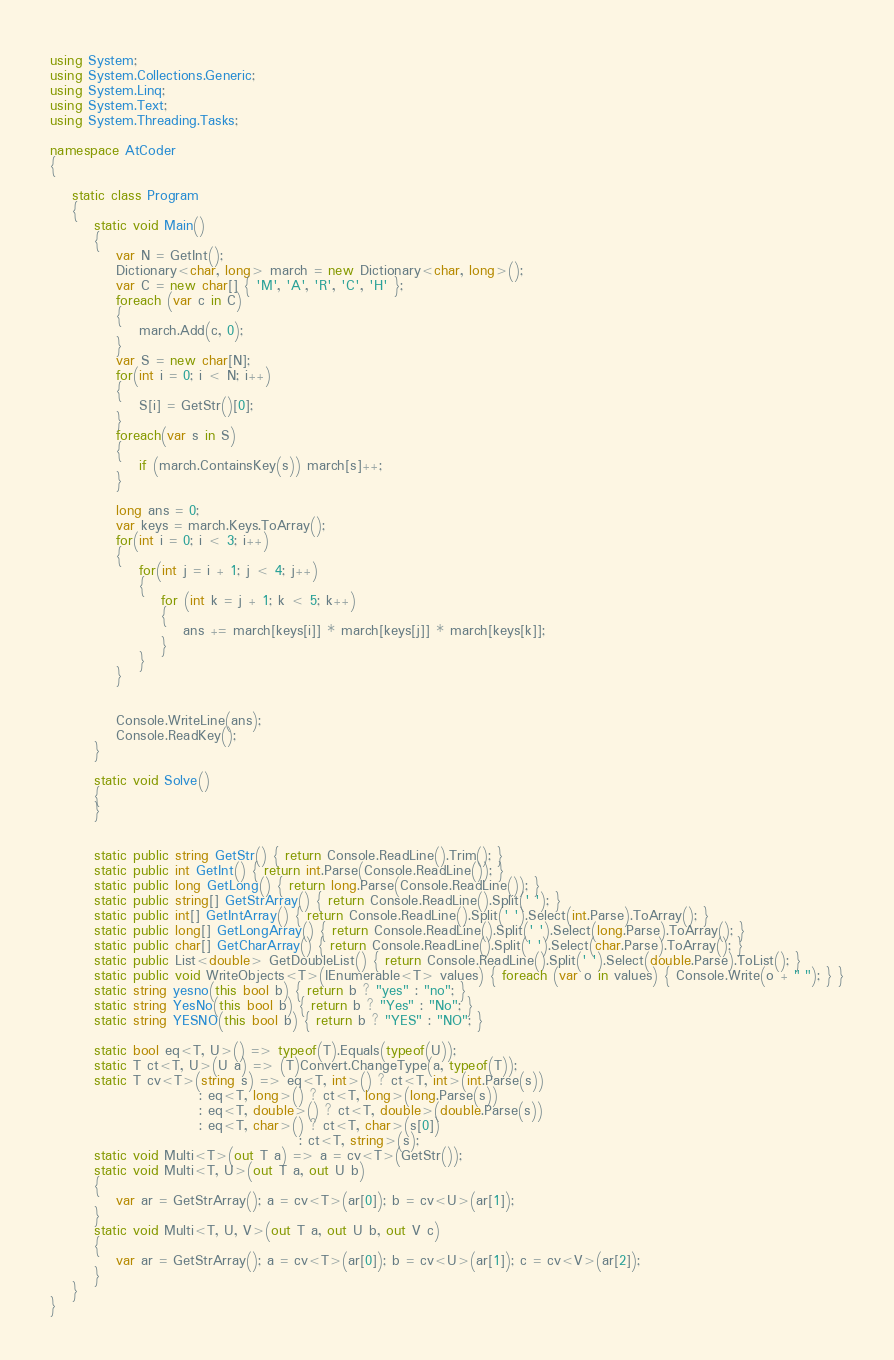<code> <loc_0><loc_0><loc_500><loc_500><_C#_>using System;
using System.Collections.Generic;
using System.Linq;
using System.Text;
using System.Threading.Tasks;

namespace AtCoder
{

    static class Program
    {
        static void Main()
        {
            var N = GetInt();
            Dictionary<char, long> march = new Dictionary<char, long>();
            var C = new char[] { 'M', 'A', 'R', 'C', 'H' };
            foreach (var c in C)
            {
                march.Add(c, 0);
            }
            var S = new char[N];
            for(int i = 0; i < N; i++)
            {
                S[i] = GetStr()[0];
            }
            foreach(var s in S)
            {
                if (march.ContainsKey(s)) march[s]++;
            }

            long ans = 0;
            var keys = march.Keys.ToArray();
            for(int i = 0; i < 3; i++)
            {
                for(int j = i + 1; j < 4; j++)
                {
                    for (int k = j + 1; k < 5; k++)
                    {
                        ans += march[keys[i]] * march[keys[j]] * march[keys[k]];
                    }
                }
            }


            Console.WriteLine(ans);
            Console.ReadKey();
        }

        static void Solve()
        {
        }


        static public string GetStr() { return Console.ReadLine().Trim(); }
        static public int GetInt() { return int.Parse(Console.ReadLine()); }
        static public long GetLong() { return long.Parse(Console.ReadLine()); }
        static public string[] GetStrArray() { return Console.ReadLine().Split(' '); }
        static public int[] GetIntArray() { return Console.ReadLine().Split(' ').Select(int.Parse).ToArray(); }
        static public long[] GetLongArray() { return Console.ReadLine().Split(' ').Select(long.Parse).ToArray(); }
        static public char[] GetCharArray() { return Console.ReadLine().Split(' ').Select(char.Parse).ToArray(); }
        static public List<double> GetDoubleList() { return Console.ReadLine().Split(' ').Select(double.Parse).ToList(); }
        static public void WriteObjects<T>(IEnumerable<T> values) { foreach (var o in values) { Console.Write(o + " "); } }
        static string yesno(this bool b) { return b ? "yes" : "no"; }
        static string YesNo(this bool b) { return b ? "Yes" : "No"; }
        static string YESNO(this bool b) { return b ? "YES" : "NO"; }

        static bool eq<T, U>() => typeof(T).Equals(typeof(U));
        static T ct<T, U>(U a) => (T)Convert.ChangeType(a, typeof(T));
        static T cv<T>(string s) => eq<T, int>() ? ct<T, int>(int.Parse(s))
                           : eq<T, long>() ? ct<T, long>(long.Parse(s))
                           : eq<T, double>() ? ct<T, double>(double.Parse(s))
                           : eq<T, char>() ? ct<T, char>(s[0])
                                             : ct<T, string>(s);
        static void Multi<T>(out T a) => a = cv<T>(GetStr());
        static void Multi<T, U>(out T a, out U b)
        {
            var ar = GetStrArray(); a = cv<T>(ar[0]); b = cv<U>(ar[1]);
        }
        static void Multi<T, U, V>(out T a, out U b, out V c)
        {
            var ar = GetStrArray(); a = cv<T>(ar[0]); b = cv<U>(ar[1]); c = cv<V>(ar[2]);
        }
    }
}</code> 